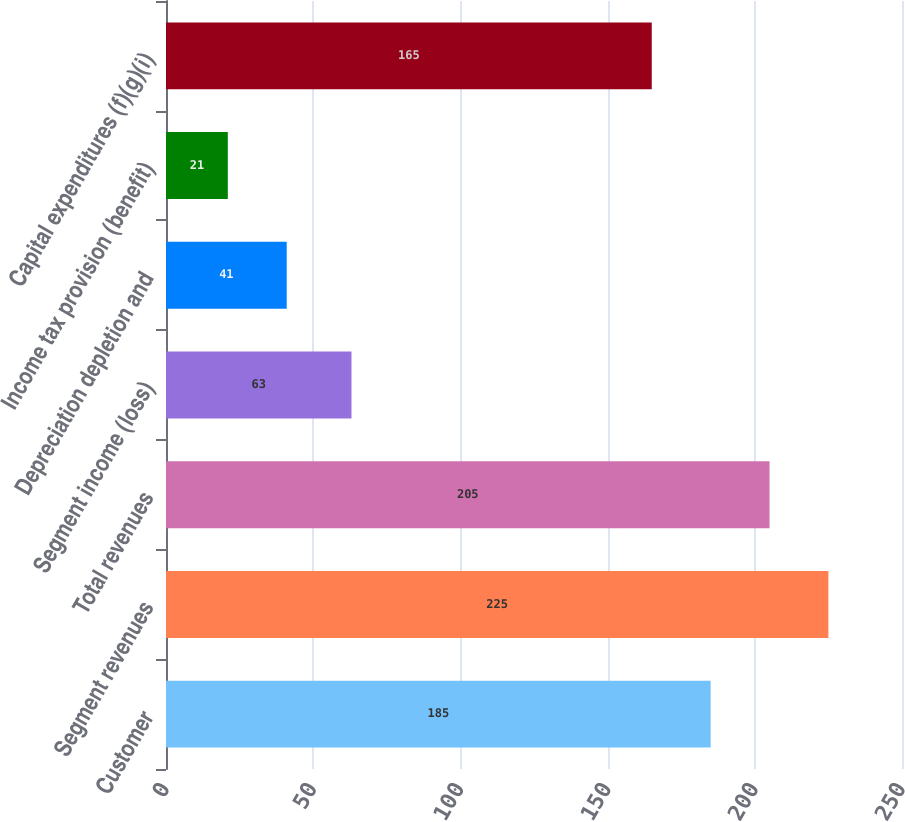<chart> <loc_0><loc_0><loc_500><loc_500><bar_chart><fcel>Customer<fcel>Segment revenues<fcel>Total revenues<fcel>Segment income (loss)<fcel>Depreciation depletion and<fcel>Income tax provision (benefit)<fcel>Capital expenditures (f)(g)(i)<nl><fcel>185<fcel>225<fcel>205<fcel>63<fcel>41<fcel>21<fcel>165<nl></chart> 